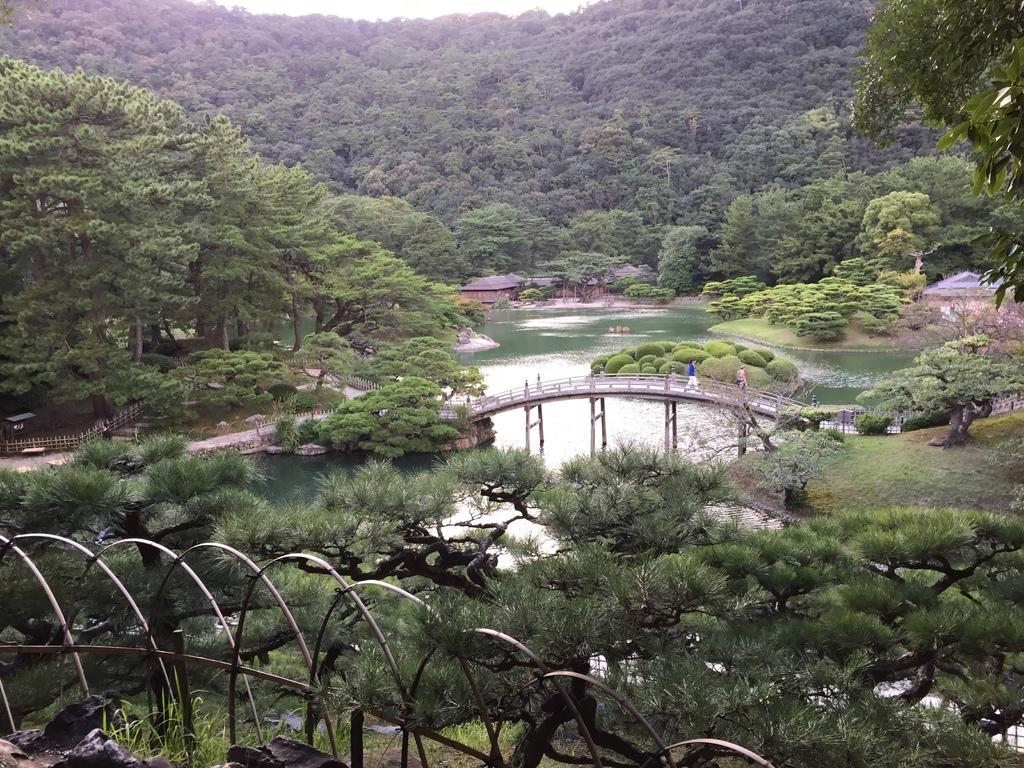What type of natural elements can be seen in the image? There are trees in the image. What man-made structure is present in the image? There is a bridge in the image. What are the people in the image doing? People are walking on the bridge. What type of buildings can be seen in the image? There are houses in the image. What body of water is visible in the image? There is water visible in the image. What type of net is being used by the people walking on the bridge in the image? There is no net present in the image; people are simply walking on the bridge. What season is depicted in the image? The provided facts do not mention any specific season, so it cannot be determined from the image. 